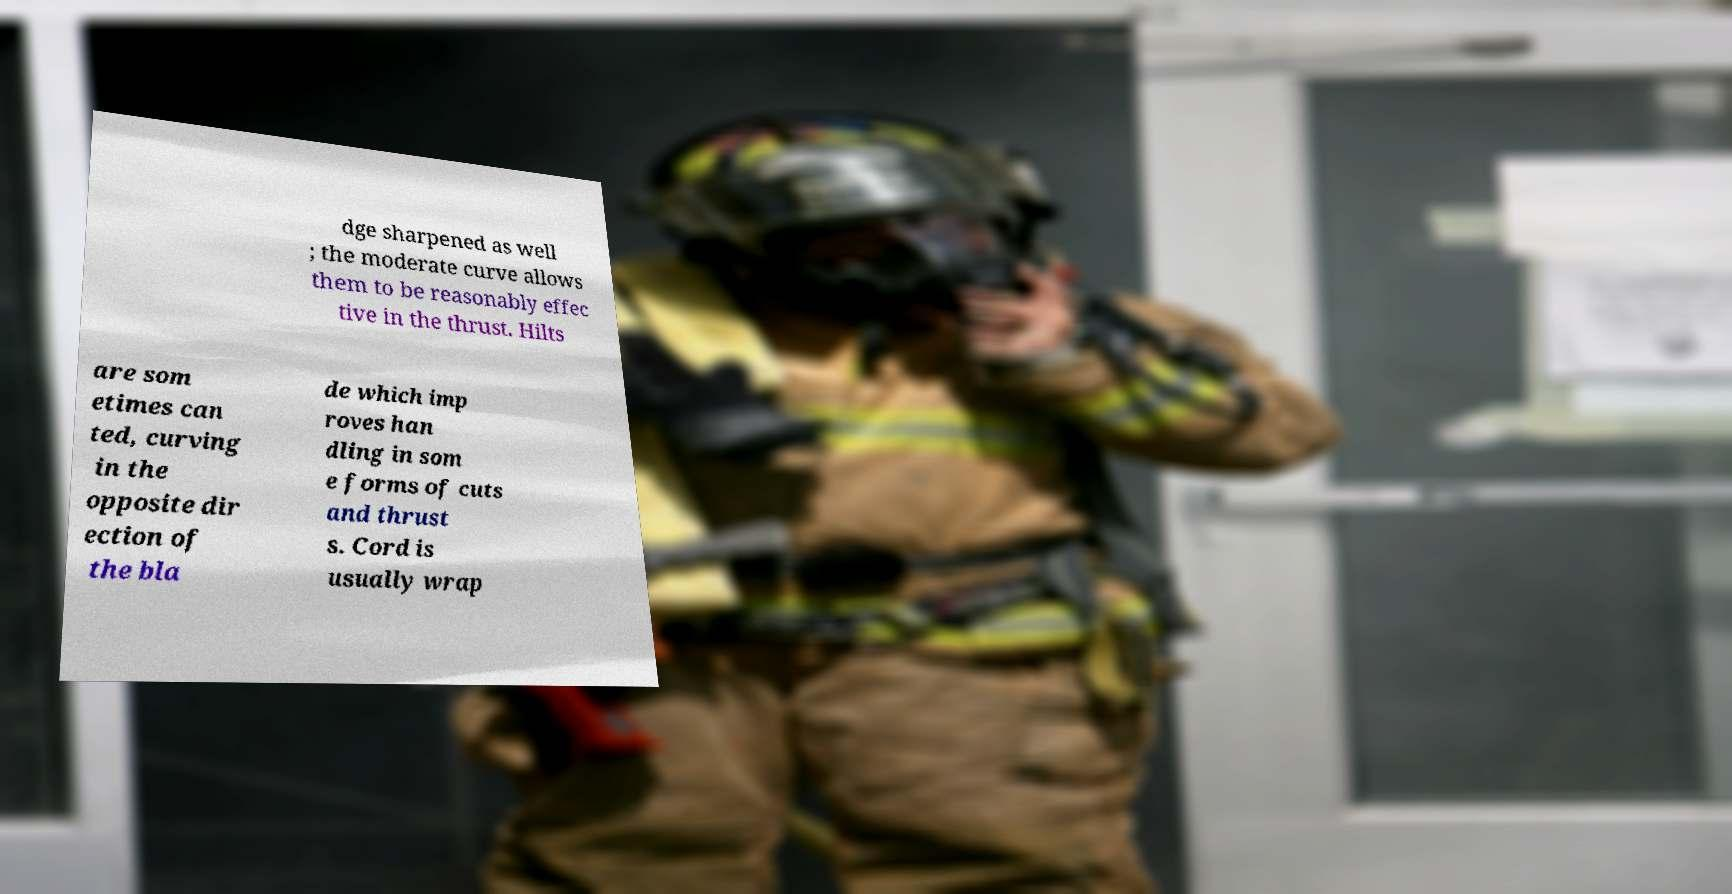Can you accurately transcribe the text from the provided image for me? dge sharpened as well ; the moderate curve allows them to be reasonably effec tive in the thrust. Hilts are som etimes can ted, curving in the opposite dir ection of the bla de which imp roves han dling in som e forms of cuts and thrust s. Cord is usually wrap 